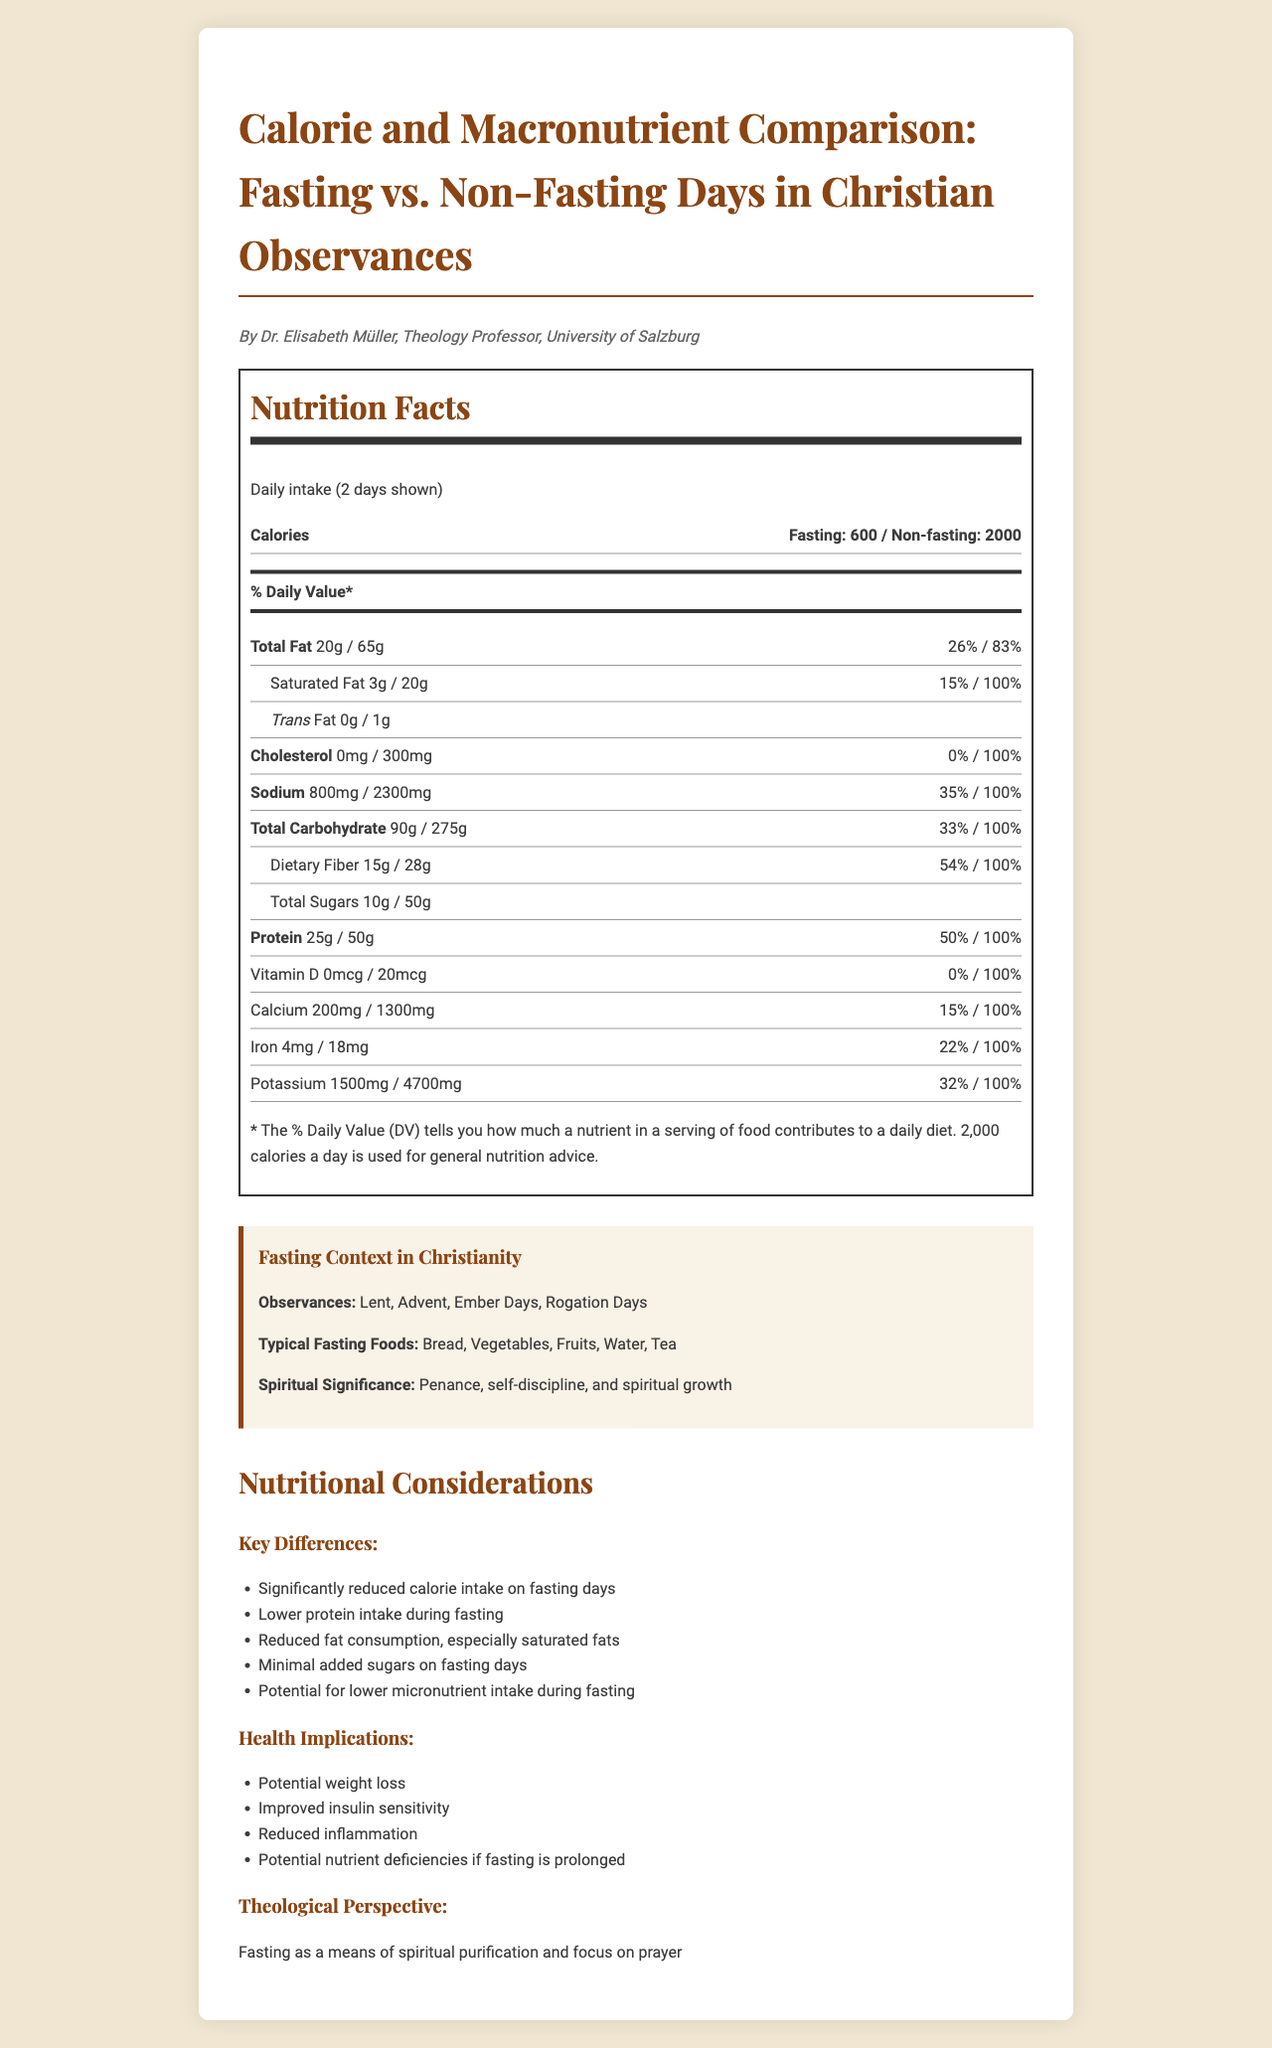what is the title of the document? The title is displayed prominently at the top of the document.
Answer: Calorie and Macronutrient Comparison: Fasting vs. Non-Fasting Days in Christian Observances who is the author of the document? The author's name and title are mentioned right below the title of the document.
Answer: Dr. Elisabeth Müller, Theology Professor, University of Salzburg how many calories are consumed on fasting days? In the Nutrition Facts section, it states "Calories: Fasting: 600".
Answer: 600 calories what is the daily value percentage of sodium on non-fasting days? The document indicates the daily value for sodium on non-fasting days is 100%.
Answer: 100% what are the typical fasting foods listed in the document? The section titled "Fasting Context in Christianity" lists typical fasting foods.
Answer: Bread, Vegetables, Fruits, Water, Tea what is the purpose of fasting in Christianity as mentioned in the document? The document describes the spiritual significance of fasting in Christianity.
Answer: Penance, self-discipline, and spiritual growth how much dietary fiber is consumed on fasting days compared to non-fasting days? The Nutrition Facts show 15g of dietary fiber on fasting days and 28g on non-fasting days.
Answer: 15g on fasting days, 28g on non-fasting days what are some health implications of fasting according to the document? A. Increased inflammation B. Improved insulin sensitivity C. Nutrient deficiencies D. Increased weight The document lists improved insulin sensitivity and potential nutrient deficiencies among the health implications.
Answer: B. Improved insulin sensitivity and C. Nutrient deficiencies which of the following observances are Christian fasting days? A. Lent B. Ramadan C. Navaratri D. Yom Kippur The document lists Lent as a Christian fasting observance.
Answer: A. Lent is there any vitamin D intake on fasting days? The Nutrition Facts indicate 0 mcg of vitamin D on fasting days.
Answer: No create a brief summary of the nutritional differences between fasting and non-fasting days as presented in the document The Nutrition Facts section highlights the significant differences between nutrient intake on fasting and non-fasting days, reflecting both calorie reduction and changes in macronutrient and micronutrient consumption.
Answer: Fasting days have significantly lower calorie intake (600 calories) compared to non-fasting days (2000 calories). Fasting days also show reduced total fat, saturated fat, cholesterol, sodium, carbohydrates, sugars, protein, and micronutrients. Key nutritional differences include lower protein and fat intake, minimal added sugars, and potential lower micronutrient levels during fasting. what are the daily value percentages for calcium on fasting and non-fasting days? The calcium daily value percentages are listed under the respective sections in the Nutrition Facts.
Answer: 15% on fasting days, 100% on non-fasting days what foods are recommended for fasting days according to the document? The document lists typical fasting foods but does not provide specific recommendations.
Answer: Not enough information 